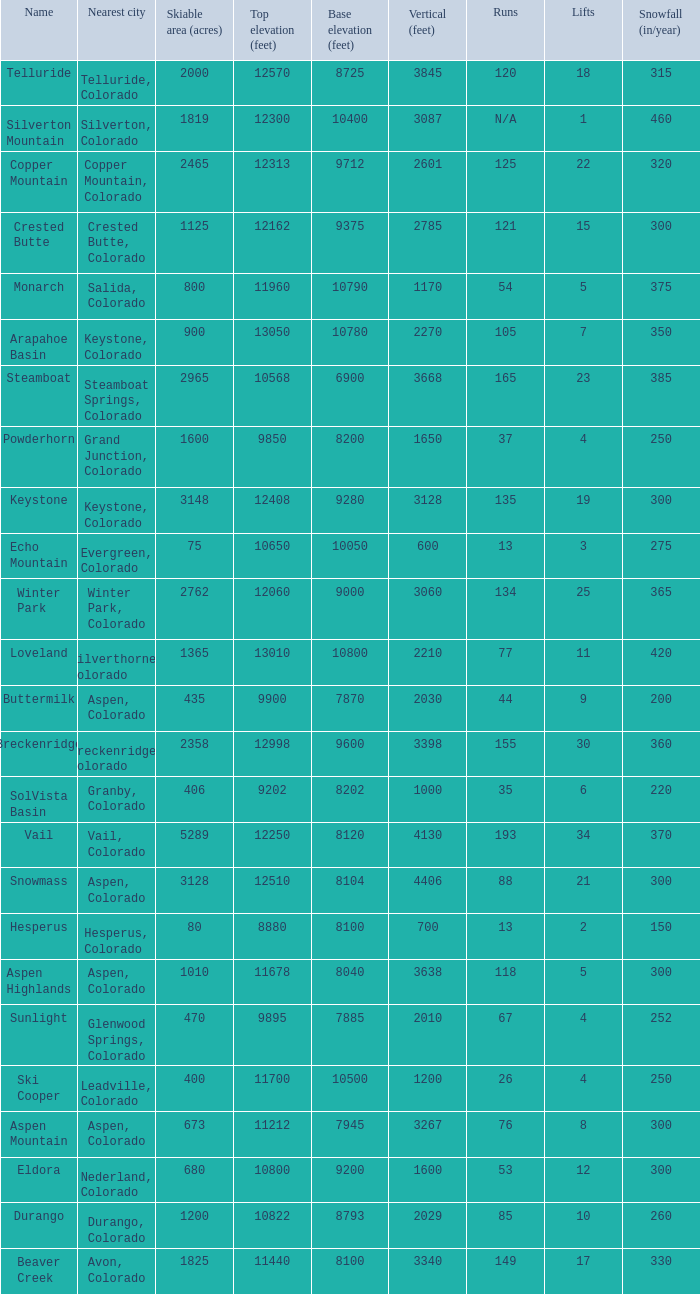Help me parse the entirety of this table. {'header': ['Name', 'Nearest city', 'Skiable area (acres)', 'Top elevation (feet)', 'Base elevation (feet)', 'Vertical (feet)', 'Runs', 'Lifts', 'Snowfall (in/year)'], 'rows': [['Telluride', 'Telluride, Colorado', '2000', '12570', '8725', '3845', '120', '18', '315'], ['Silverton Mountain', 'Silverton, Colorado', '1819', '12300', '10400', '3087', 'N/A', '1', '460'], ['Copper Mountain', 'Copper Mountain, Colorado', '2465', '12313', '9712', '2601', '125', '22', '320'], ['Crested Butte', 'Crested Butte, Colorado', '1125', '12162', '9375', '2785', '121', '15', '300'], ['Monarch', 'Salida, Colorado', '800', '11960', '10790', '1170', '54', '5', '375'], ['Arapahoe Basin', 'Keystone, Colorado', '900', '13050', '10780', '2270', '105', '7', '350'], ['Steamboat', 'Steamboat Springs, Colorado', '2965', '10568', '6900', '3668', '165', '23', '385'], ['Powderhorn', 'Grand Junction, Colorado', '1600', '9850', '8200', '1650', '37', '4', '250'], ['Keystone', 'Keystone, Colorado', '3148', '12408', '9280', '3128', '135', '19', '300'], ['Echo Mountain', 'Evergreen, Colorado', '75', '10650', '10050', '600', '13', '3', '275'], ['Winter Park', 'Winter Park, Colorado', '2762', '12060', '9000', '3060', '134', '25', '365'], ['Loveland', 'Silverthorne, Colorado', '1365', '13010', '10800', '2210', '77', '11', '420'], ['Buttermilk', 'Aspen, Colorado', '435', '9900', '7870', '2030', '44', '9', '200'], ['Breckenridge', 'Breckenridge, Colorado', '2358', '12998', '9600', '3398', '155', '30', '360'], ['SolVista Basin', 'Granby, Colorado', '406', '9202', '8202', '1000', '35', '6', '220'], ['Vail', 'Vail, Colorado', '5289', '12250', '8120', '4130', '193', '34', '370'], ['Snowmass', 'Aspen, Colorado', '3128', '12510', '8104', '4406', '88', '21', '300'], ['Hesperus', 'Hesperus, Colorado', '80', '8880', '8100', '700', '13', '2', '150'], ['Aspen Highlands', 'Aspen, Colorado', '1010', '11678', '8040', '3638', '118', '5', '300'], ['Sunlight', 'Glenwood Springs, Colorado', '470', '9895', '7885', '2010', '67', '4', '252'], ['Ski Cooper', 'Leadville, Colorado', '400', '11700', '10500', '1200', '26', '4', '250'], ['Aspen Mountain', 'Aspen, Colorado', '673', '11212', '7945', '3267', '76', '8', '300'], ['Eldora', 'Nederland, Colorado', '680', '10800', '9200', '1600', '53', '12', '300'], ['Durango', 'Durango, Colorado', '1200', '10822', '8793', '2029', '85', '10', '260'], ['Beaver Creek', 'Avon, Colorado', '1825', '11440', '8100', '3340', '149', '17', '330']]} If the name is Steamboat, what is the top elevation? 10568.0. 